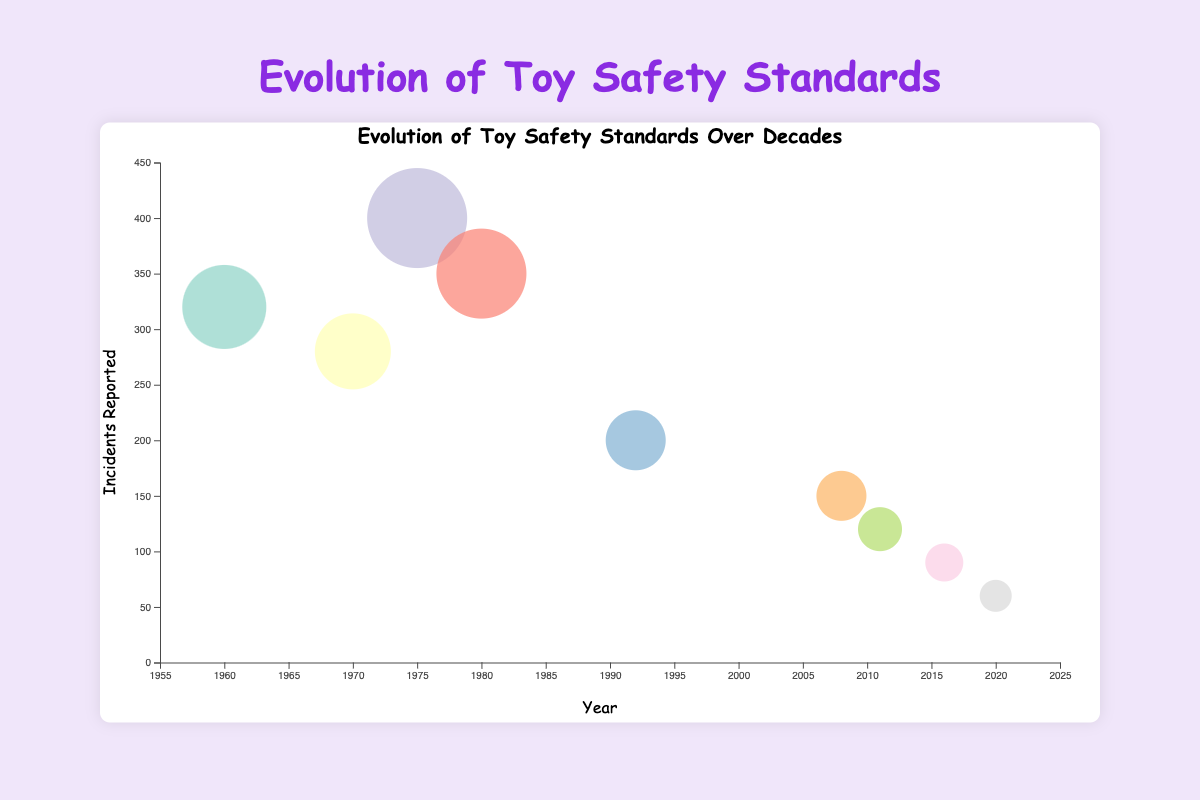What is the title of the chart? The title of the chart is displayed at the top center and reads "Evolution of Toy Safety Standards Over Decades."
Answer: Evolution of Toy Safety Standards Over Decades What does the x-axis represent? The x-axis, located at the bottom of the chart, represents the year in which toy safety standards were introduced or updated, ranging from 1955 to 2025.
Answer: Year Which safety standard had the highest number of incidents reported and in what year? The largest bubble on the chart indicates the highest number of incidents reported, showing 400 incidents. This corresponds to the "ASTM F963" standard introduced in 1975.
Answer: ASTM F963 in 1975 What colors are used to represent different standards? Each bubble (representing a standard) has a unique color filled, with colors drawn from a diverse palette (e.g., pink, green, blue, etc.), making each standard visually distinct.
Answer: Various distinct colors How does the number of incidents reported change from 1960 to 2020? By observing bubble sizes and positions from 1960 to 2020, we see fluctuations but a trend of declining incident numbers over time, with noticeable large bubbles in the early years and smaller bubbles in recent years.
Answer: Decreases over time Compare the number of incidents reported in 1980 and 2008. The bubble representing 1980 has 350 incidents reported, while the bubble for 2008 shows 150 incidents. By comparing these values, it is evident incident reports decreased by 200 over these years.
Answer: 200 fewer incidents in 2008 than in 1980 Which standard corresponds to the smallest bubble, and how many incidents were reported? The smallest bubble, indicating the lowest incidents, corresponds to the "Cybersecurity for Connected Toys" standard introduced in 2020, with 60 incidents reported.
Answer: Cybersecurity for Connected Toys with 60 incidents Between which years did the incidents reported experience the largest decline? Observing bubble sizes and their corresponding years, the most substantial decrease in sizes occurs between 1975 (400 incidents) and 1992 (200 incidents), indicating a drop of 200 incidents.
Answer: 1975 to 1992 How many incidents were reported in 1992, and what was the corresponding standard? The bubble for 1992 is relatively smaller and indicates 200 incidents reported. This corresponds to the "Heavy Metal Restrictions" standard.
Answer: 200 incidents, Heavy Metal Restrictions Identify two consecutive time periods where incidents decreased significantly. Comparing consecutive bubbles, significant decreases are observed from 1975 (ASTM F963 with 400 incidents) to 1980 (Choking Hazard Warning with 350 incidents), and from 2008 (Consumer Product Safety Improvement Act with 150 incidents) to 2011 (EN 71-1 Adjustment with 120 incidents).
Answer: 1975 to 1980 and 2008 to 2011 